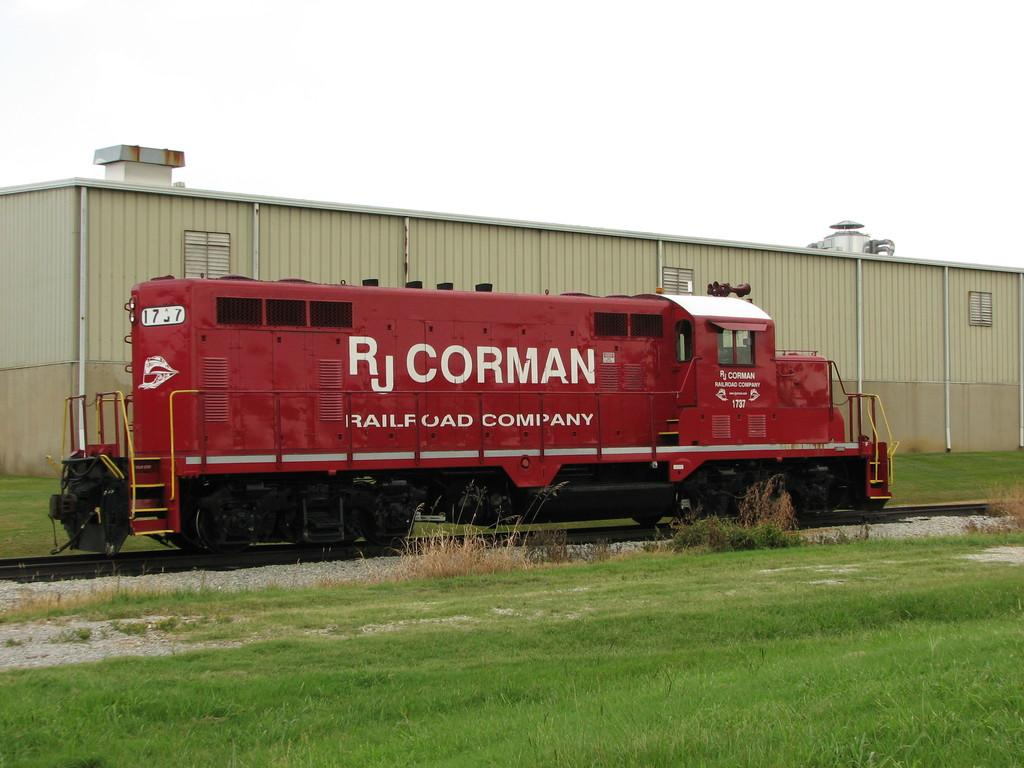<image>
Summarize the visual content of the image. A red railway car that says RJ Corman on its side is parked. 